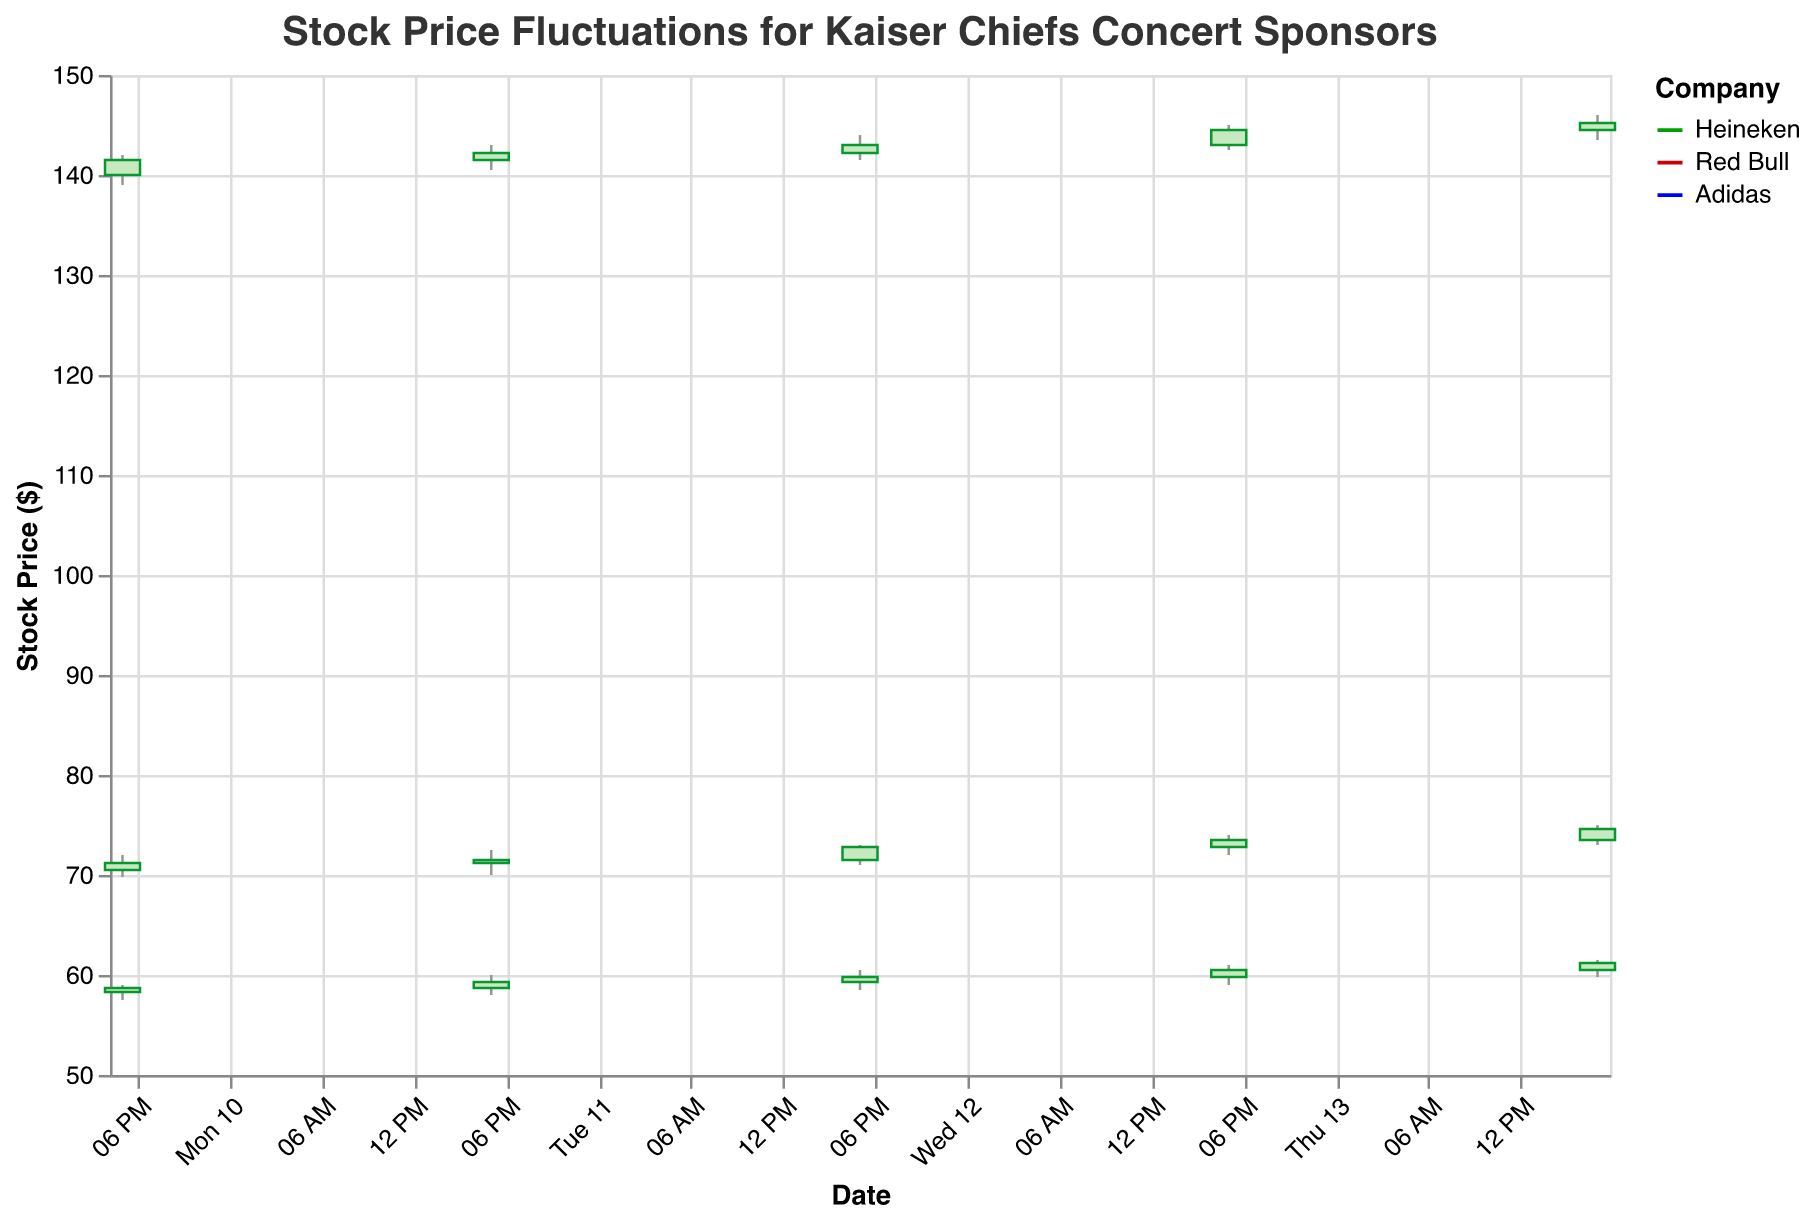What is the highest closing price for Heineken during the specified dates? Look for the highest close price for Heineken between July 10 and July 14. It is $74.60 on July 14.
Answer: $74.60 Which company had the highest trading volume on July 14, 2023? Compare the trading volumes for Heineken, Red Bull, and Adidas on July 14. Heineken had the highest volume at 3,000,000 shares.
Answer: Heineken Did Red Bull's closing price ever reach $60 or more during the specified dates? Check the closing prices for Red Bull from July 10 to July 14. The closing prices on July 13 and July 14 were $60.50 and $61.20, respectively.
Answer: Yes How did Adidas' stock price trend from July 10 to July 14, 2023? Observe the opening and closing prices for each day between July 10 and July 14. The stock opened at $140.00 on July 10 and consistently increased, closing at $145.20 on July 14.
Answer: Increasing Which date had the lowest closing price for any company? Compare the closing prices for all three companies between July 10 and July 14. The lowest closing price was Heineken at $71.20 on July 10.
Answer: July 10 What was the percentage increase in Heineken's closing price from July 10 to July 14, 2023? The closing price on July 10 was $71.20 and on July 14 was $74.60. The percentage increase is calculated as [(74.60 - 71.20) / 71.20] * 100 ≈ 4.78%.
Answer: 4.78% Between Red Bull and Adidas, which company showed more volatility in their stock prices? Assess the range between the highest and lowest stock prices for both companies from July 10 to July 14. Red Bull's range (59.00 - 57.50 = 1.50) is less than Adidas' range (146.00 - 139.00 = 7.00), indicating Adidas was more volatile.
Answer: Adidas How many days did Heineken's stock close higher than its opening price from July 10 to July 14, 2023? Compare the opening and closing prices for each day. Heineken’s stock closed higher than its opening price on July 10, 11, 13, and 14.
Answer: 4 days Which company had the largest single-day price increase, and on what date? Calculate the difference between the opening and closing prices for each company on all dates. Adidas had the largest single-day increase of $1.70 on July 12.
Answer: Adidas on July 12 